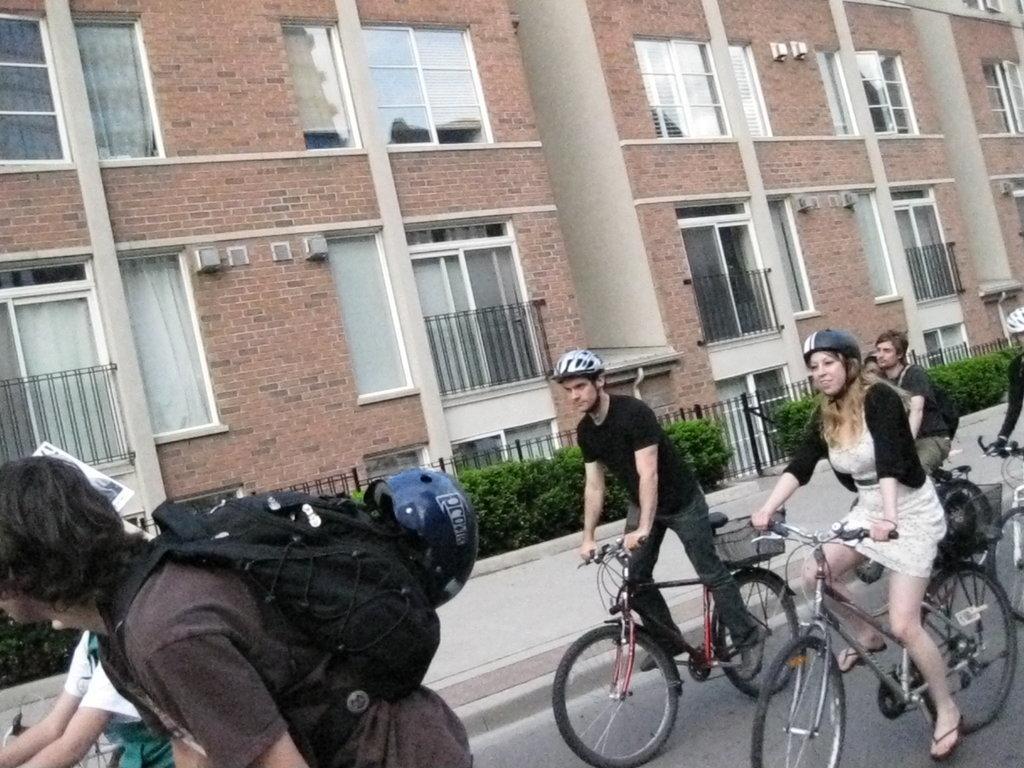How would you summarize this image in a sentence or two? The image is outside of the city and there are group of people who are riding their bicycles. In middle there are two people both man and woman are riding their bicycles and also wearing their helmets. On left side there is a man who is riding his bicycle and wearing his bag. In background there are buildings,windows,plants,footpath. 